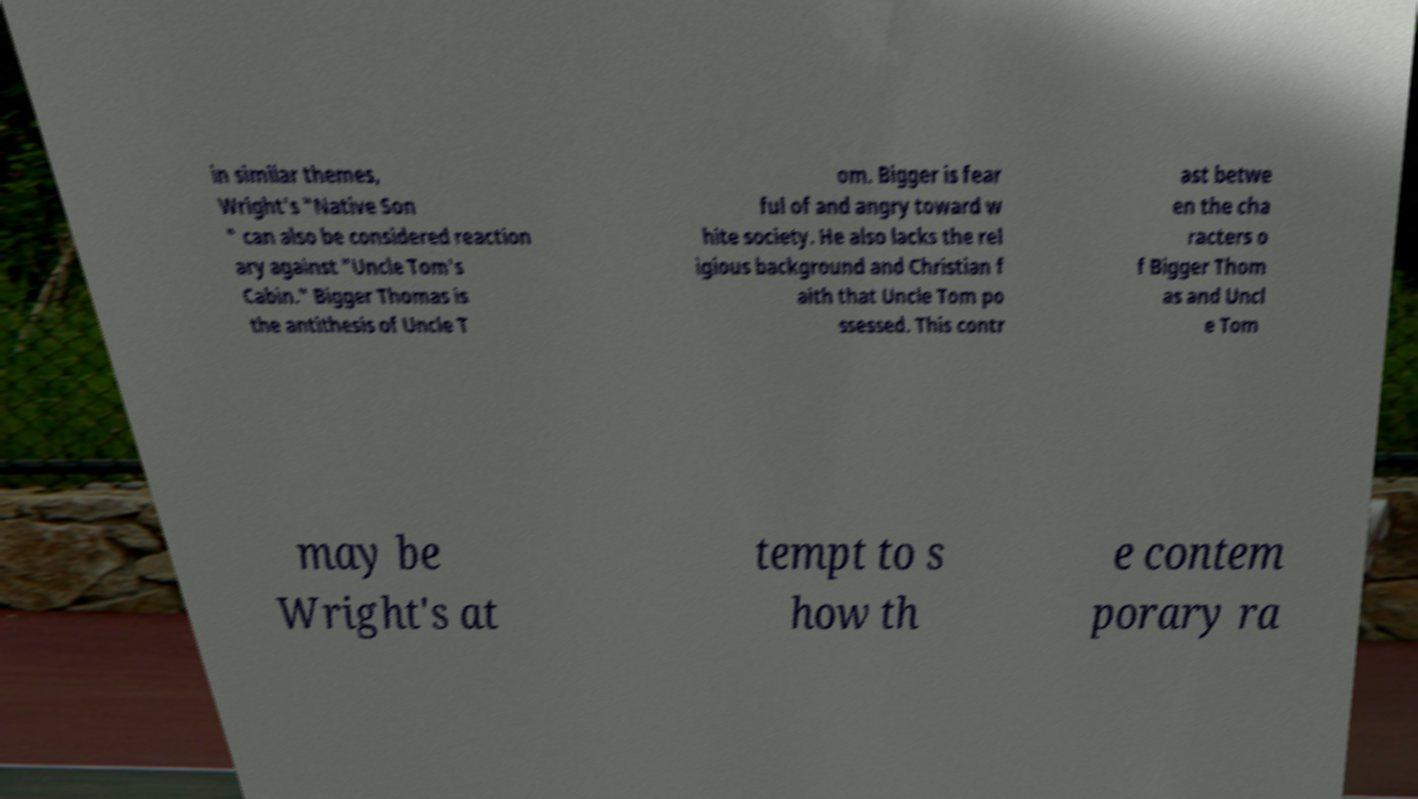Can you read and provide the text displayed in the image?This photo seems to have some interesting text. Can you extract and type it out for me? in similar themes, Wright's "Native Son " can also be considered reaction ary against "Uncle Tom's Cabin." Bigger Thomas is the antithesis of Uncle T om. Bigger is fear ful of and angry toward w hite society. He also lacks the rel igious background and Christian f aith that Uncle Tom po ssessed. This contr ast betwe en the cha racters o f Bigger Thom as and Uncl e Tom may be Wright's at tempt to s how th e contem porary ra 